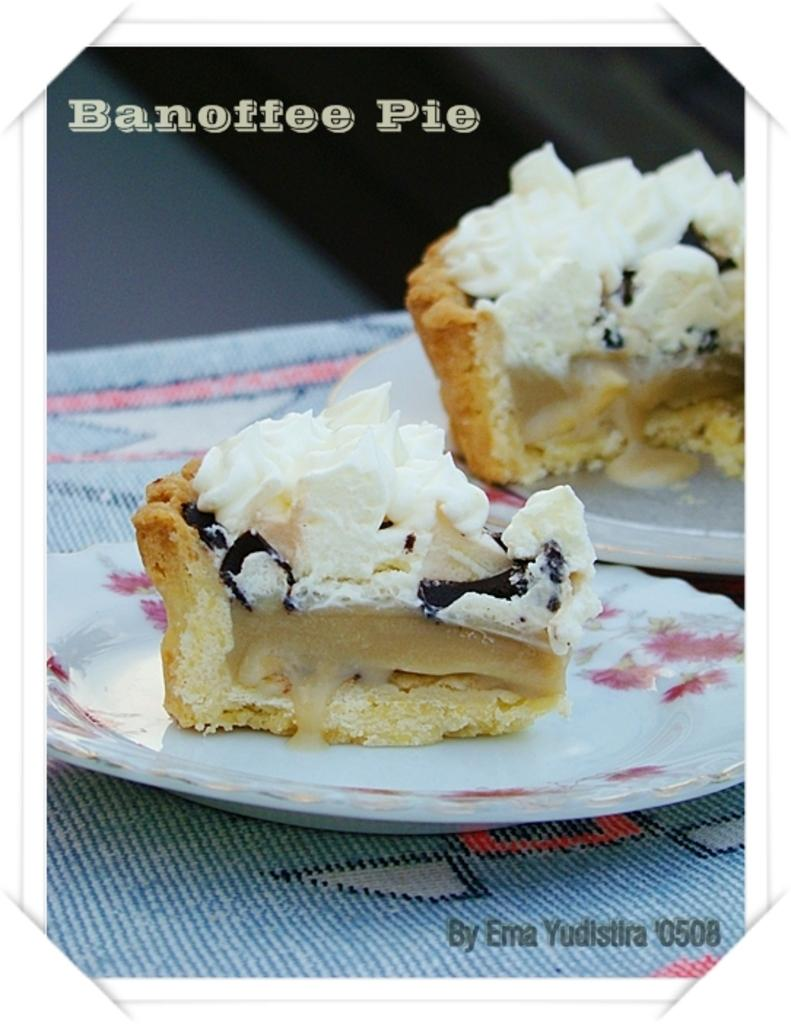What is on the floor in the image? There is a mat on the floor in the image. What is placed on the mat? There are two plates on the mat. What is on each plate? Each plate has a piece of cake on it. What type of chalk is being used to draw on the mat? There is no chalk present in the image, and no drawing is taking place on the mat. 